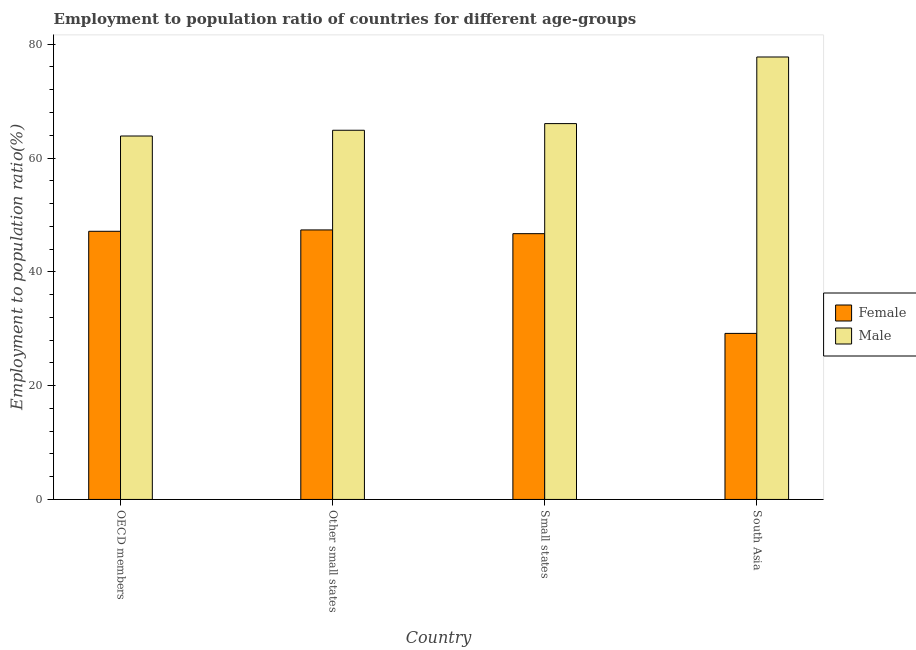How many groups of bars are there?
Give a very brief answer. 4. Are the number of bars per tick equal to the number of legend labels?
Provide a short and direct response. Yes. Are the number of bars on each tick of the X-axis equal?
Offer a terse response. Yes. What is the label of the 2nd group of bars from the left?
Your response must be concise. Other small states. In how many cases, is the number of bars for a given country not equal to the number of legend labels?
Your answer should be compact. 0. What is the employment to population ratio(male) in Small states?
Offer a very short reply. 66.05. Across all countries, what is the maximum employment to population ratio(male)?
Offer a terse response. 77.75. Across all countries, what is the minimum employment to population ratio(male)?
Give a very brief answer. 63.87. In which country was the employment to population ratio(female) maximum?
Offer a very short reply. Other small states. What is the total employment to population ratio(male) in the graph?
Offer a terse response. 272.55. What is the difference between the employment to population ratio(male) in Other small states and that in South Asia?
Keep it short and to the point. -12.87. What is the difference between the employment to population ratio(female) in Small states and the employment to population ratio(male) in South Asia?
Offer a terse response. -31.05. What is the average employment to population ratio(female) per country?
Your answer should be very brief. 42.59. What is the difference between the employment to population ratio(female) and employment to population ratio(male) in OECD members?
Provide a succinct answer. -16.74. What is the ratio of the employment to population ratio(female) in OECD members to that in Small states?
Offer a very short reply. 1.01. Is the employment to population ratio(male) in Other small states less than that in Small states?
Your answer should be very brief. Yes. Is the difference between the employment to population ratio(male) in Small states and South Asia greater than the difference between the employment to population ratio(female) in Small states and South Asia?
Your answer should be very brief. No. What is the difference between the highest and the second highest employment to population ratio(male)?
Keep it short and to the point. 11.7. What is the difference between the highest and the lowest employment to population ratio(female)?
Provide a short and direct response. 18.18. What does the 1st bar from the right in Other small states represents?
Keep it short and to the point. Male. Are all the bars in the graph horizontal?
Provide a short and direct response. No. What is the difference between two consecutive major ticks on the Y-axis?
Your answer should be compact. 20. Are the values on the major ticks of Y-axis written in scientific E-notation?
Make the answer very short. No. Does the graph contain any zero values?
Provide a short and direct response. No. Does the graph contain grids?
Make the answer very short. No. How many legend labels are there?
Your response must be concise. 2. How are the legend labels stacked?
Your response must be concise. Vertical. What is the title of the graph?
Provide a short and direct response. Employment to population ratio of countries for different age-groups. What is the label or title of the Y-axis?
Offer a very short reply. Employment to population ratio(%). What is the Employment to population ratio(%) in Female in OECD members?
Your answer should be compact. 47.13. What is the Employment to population ratio(%) of Male in OECD members?
Give a very brief answer. 63.87. What is the Employment to population ratio(%) in Female in Other small states?
Keep it short and to the point. 47.36. What is the Employment to population ratio(%) of Male in Other small states?
Give a very brief answer. 64.88. What is the Employment to population ratio(%) in Female in Small states?
Your response must be concise. 46.71. What is the Employment to population ratio(%) in Male in Small states?
Give a very brief answer. 66.05. What is the Employment to population ratio(%) of Female in South Asia?
Your response must be concise. 29.18. What is the Employment to population ratio(%) in Male in South Asia?
Make the answer very short. 77.75. Across all countries, what is the maximum Employment to population ratio(%) of Female?
Offer a very short reply. 47.36. Across all countries, what is the maximum Employment to population ratio(%) in Male?
Offer a very short reply. 77.75. Across all countries, what is the minimum Employment to population ratio(%) of Female?
Your answer should be compact. 29.18. Across all countries, what is the minimum Employment to population ratio(%) of Male?
Your answer should be compact. 63.87. What is the total Employment to population ratio(%) of Female in the graph?
Offer a terse response. 170.38. What is the total Employment to population ratio(%) in Male in the graph?
Give a very brief answer. 272.55. What is the difference between the Employment to population ratio(%) of Female in OECD members and that in Other small states?
Offer a terse response. -0.24. What is the difference between the Employment to population ratio(%) of Male in OECD members and that in Other small states?
Provide a succinct answer. -1.01. What is the difference between the Employment to population ratio(%) of Female in OECD members and that in Small states?
Provide a short and direct response. 0.42. What is the difference between the Employment to population ratio(%) of Male in OECD members and that in Small states?
Make the answer very short. -2.18. What is the difference between the Employment to population ratio(%) of Female in OECD members and that in South Asia?
Offer a very short reply. 17.94. What is the difference between the Employment to population ratio(%) in Male in OECD members and that in South Asia?
Offer a terse response. -13.89. What is the difference between the Employment to population ratio(%) in Female in Other small states and that in Small states?
Offer a terse response. 0.66. What is the difference between the Employment to population ratio(%) in Male in Other small states and that in Small states?
Your answer should be compact. -1.17. What is the difference between the Employment to population ratio(%) of Female in Other small states and that in South Asia?
Offer a terse response. 18.18. What is the difference between the Employment to population ratio(%) of Male in Other small states and that in South Asia?
Provide a short and direct response. -12.87. What is the difference between the Employment to population ratio(%) in Female in Small states and that in South Asia?
Provide a short and direct response. 17.53. What is the difference between the Employment to population ratio(%) of Male in Small states and that in South Asia?
Make the answer very short. -11.7. What is the difference between the Employment to population ratio(%) of Female in OECD members and the Employment to population ratio(%) of Male in Other small states?
Ensure brevity in your answer.  -17.75. What is the difference between the Employment to population ratio(%) in Female in OECD members and the Employment to population ratio(%) in Male in Small states?
Provide a short and direct response. -18.92. What is the difference between the Employment to population ratio(%) of Female in OECD members and the Employment to population ratio(%) of Male in South Asia?
Make the answer very short. -30.63. What is the difference between the Employment to population ratio(%) in Female in Other small states and the Employment to population ratio(%) in Male in Small states?
Offer a terse response. -18.68. What is the difference between the Employment to population ratio(%) in Female in Other small states and the Employment to population ratio(%) in Male in South Asia?
Make the answer very short. -30.39. What is the difference between the Employment to population ratio(%) of Female in Small states and the Employment to population ratio(%) of Male in South Asia?
Your answer should be very brief. -31.05. What is the average Employment to population ratio(%) in Female per country?
Offer a terse response. 42.59. What is the average Employment to population ratio(%) in Male per country?
Your response must be concise. 68.14. What is the difference between the Employment to population ratio(%) in Female and Employment to population ratio(%) in Male in OECD members?
Offer a terse response. -16.74. What is the difference between the Employment to population ratio(%) in Female and Employment to population ratio(%) in Male in Other small states?
Your response must be concise. -17.52. What is the difference between the Employment to population ratio(%) in Female and Employment to population ratio(%) in Male in Small states?
Your response must be concise. -19.34. What is the difference between the Employment to population ratio(%) of Female and Employment to population ratio(%) of Male in South Asia?
Give a very brief answer. -48.57. What is the ratio of the Employment to population ratio(%) in Male in OECD members to that in Other small states?
Make the answer very short. 0.98. What is the ratio of the Employment to population ratio(%) in Female in OECD members to that in Small states?
Your response must be concise. 1.01. What is the ratio of the Employment to population ratio(%) of Female in OECD members to that in South Asia?
Your answer should be compact. 1.61. What is the ratio of the Employment to population ratio(%) of Male in OECD members to that in South Asia?
Offer a very short reply. 0.82. What is the ratio of the Employment to population ratio(%) in Female in Other small states to that in Small states?
Ensure brevity in your answer.  1.01. What is the ratio of the Employment to population ratio(%) of Male in Other small states to that in Small states?
Ensure brevity in your answer.  0.98. What is the ratio of the Employment to population ratio(%) of Female in Other small states to that in South Asia?
Provide a succinct answer. 1.62. What is the ratio of the Employment to population ratio(%) of Male in Other small states to that in South Asia?
Keep it short and to the point. 0.83. What is the ratio of the Employment to population ratio(%) in Female in Small states to that in South Asia?
Give a very brief answer. 1.6. What is the ratio of the Employment to population ratio(%) of Male in Small states to that in South Asia?
Your answer should be compact. 0.85. What is the difference between the highest and the second highest Employment to population ratio(%) in Female?
Ensure brevity in your answer.  0.24. What is the difference between the highest and the second highest Employment to population ratio(%) of Male?
Provide a short and direct response. 11.7. What is the difference between the highest and the lowest Employment to population ratio(%) of Female?
Your answer should be very brief. 18.18. What is the difference between the highest and the lowest Employment to population ratio(%) of Male?
Your answer should be compact. 13.89. 